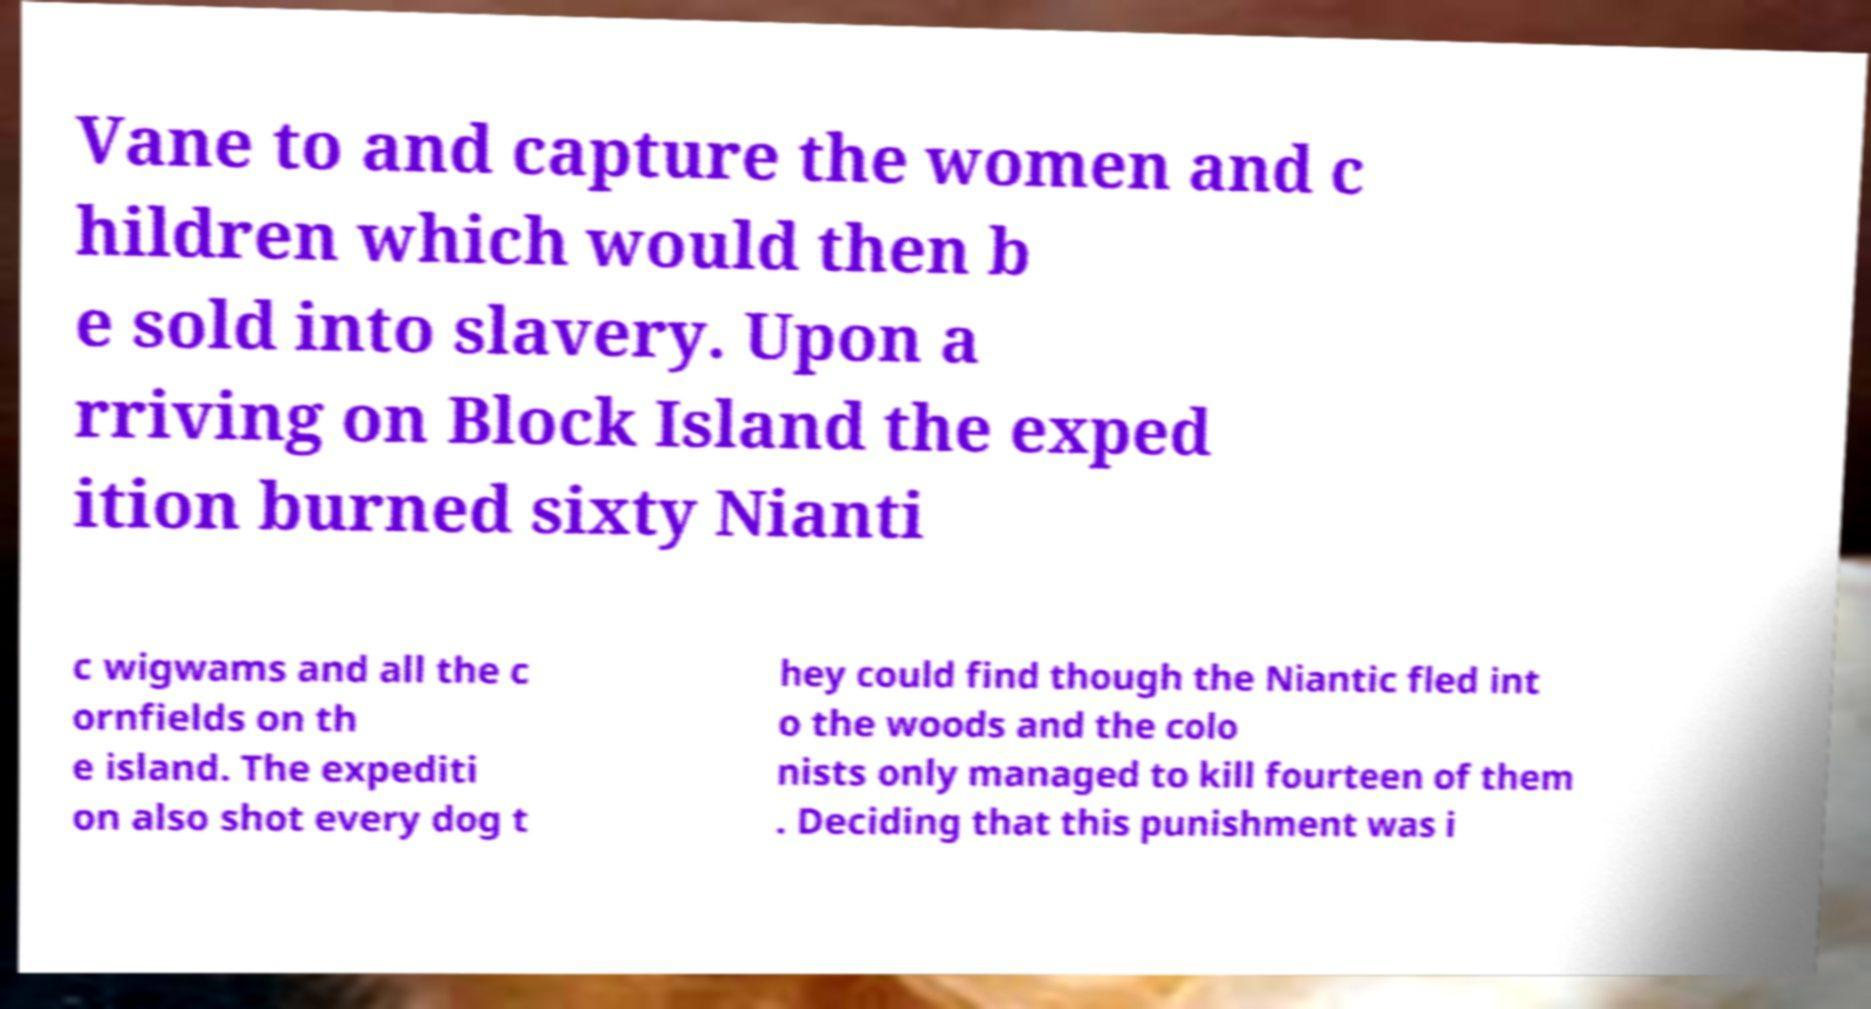Please read and relay the text visible in this image. What does it say? Vane to and capture the women and c hildren which would then b e sold into slavery. Upon a rriving on Block Island the exped ition burned sixty Nianti c wigwams and all the c ornfields on th e island. The expediti on also shot every dog t hey could find though the Niantic fled int o the woods and the colo nists only managed to kill fourteen of them . Deciding that this punishment was i 